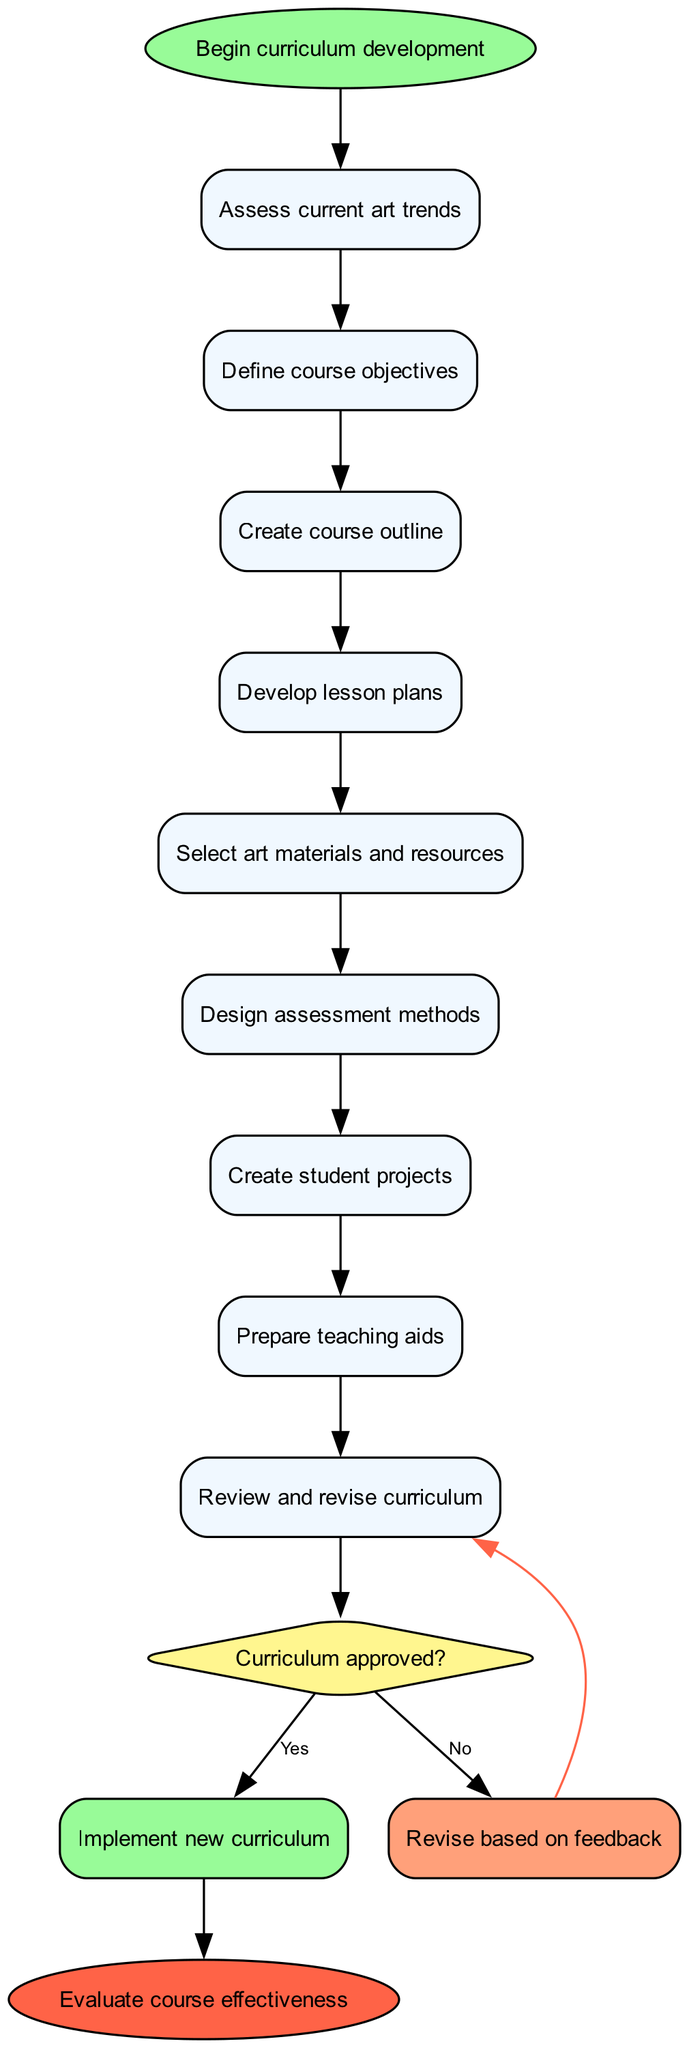What is the first activity in the diagram? The diagram shows that the first activity after starting is "Assess current art trends." This is identified as the first node connected to the start node.
Answer: Assess current art trends How many activities are listed in the diagram? The diagram contains a total of eight distinct activities that are presented sequentially. Counting them gives the total number.
Answer: Eight What happens if the curriculum is not approved? If the curriculum is not approved, the flow indicates going to the "Revise based on feedback" node, which is attached to the decision node.
Answer: Revise based on feedback Which activity leads to the decision point? The decision point follows the last activity, which is "Design assessment methods." This is the final activity before reaching the decision node.
Answer: Design assessment methods What is the outcome if the curriculum is approved? If the curriculum is approved, the diagram shows an edge leading directly to the "Evaluate course effectiveness" node, indicating that evaluation follows approval.
Answer: Implement new curriculum How many edges connect the activities in the diagram? Each activity has at least one edge connecting it to the next, resulting in a count of eight edges connecting the eight activities plus two edges leading from the decision node, totaling ten.
Answer: Ten What shape is used for the decision node? The decision node is represented using the diamond shape, which is a standard representation for decision points in activity diagrams.
Answer: Diamond What is the final step in the process represented in the diagram? The last step in the process is "Evaluate course effectiveness," which is linked to the successful implementation of the curriculum after approval.
Answer: Evaluate course effectiveness 